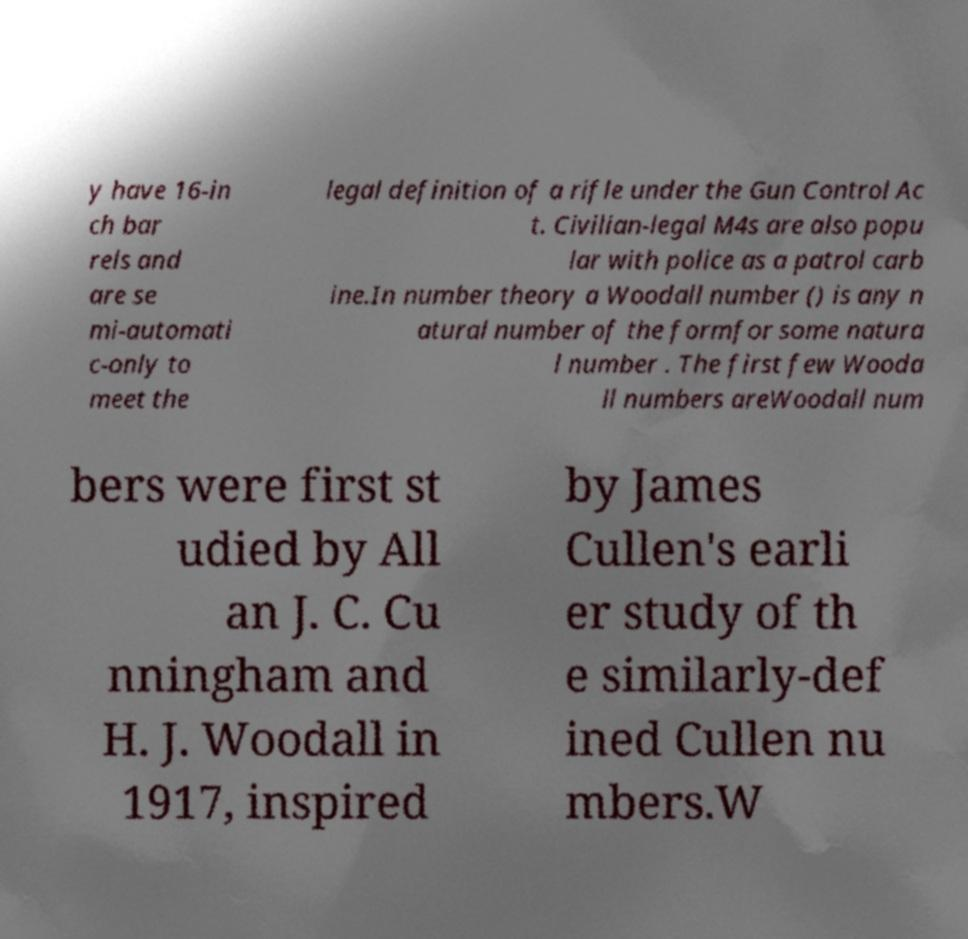Could you assist in decoding the text presented in this image and type it out clearly? y have 16-in ch bar rels and are se mi-automati c-only to meet the legal definition of a rifle under the Gun Control Ac t. Civilian-legal M4s are also popu lar with police as a patrol carb ine.In number theory a Woodall number () is any n atural number of the formfor some natura l number . The first few Wooda ll numbers areWoodall num bers were first st udied by All an J. C. Cu nningham and H. J. Woodall in 1917, inspired by James Cullen's earli er study of th e similarly-def ined Cullen nu mbers.W 